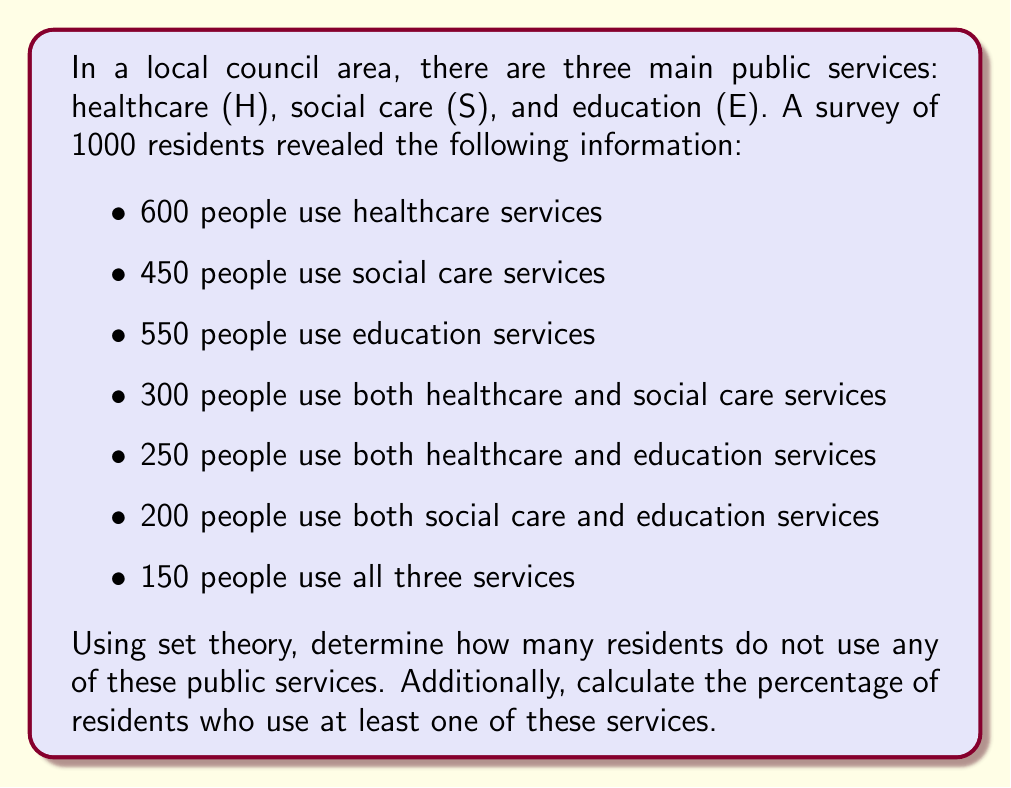Provide a solution to this math problem. Let's approach this problem step-by-step using set theory:

1) First, let's define our universal set U as all 1000 residents surveyed.

2) We can use the inclusion-exclusion principle to find the number of residents who use at least one service:

   $$|H \cup S \cup E| = |H| + |S| + |E| - |H \cap S| - |H \cap E| - |S \cap E| + |H \cap S \cap E|$$

3) Substituting the given values:

   $$|H \cup S \cup E| = 600 + 450 + 550 - 300 - 250 - 200 + 150 = 1000$$

4) This means that 1000 residents use at least one service.

5) To find the number of residents who don't use any service, we subtract this from the total number of residents:

   $$|U| - |H \cup S \cup E| = 1000 - 1000 = 0$$

6) To calculate the percentage of residents who use at least one service:

   $$\frac{|H \cup S \cup E|}{|U|} \times 100\% = \frac{1000}{1000} \times 100\% = 100\%$$

This result shows that all residents in the survey use at least one public service, highlighting the importance of maintaining robust public services rather than privatizing them.
Answer: 0 residents do not use any of these public services.
100% of residents use at least one of these services. 